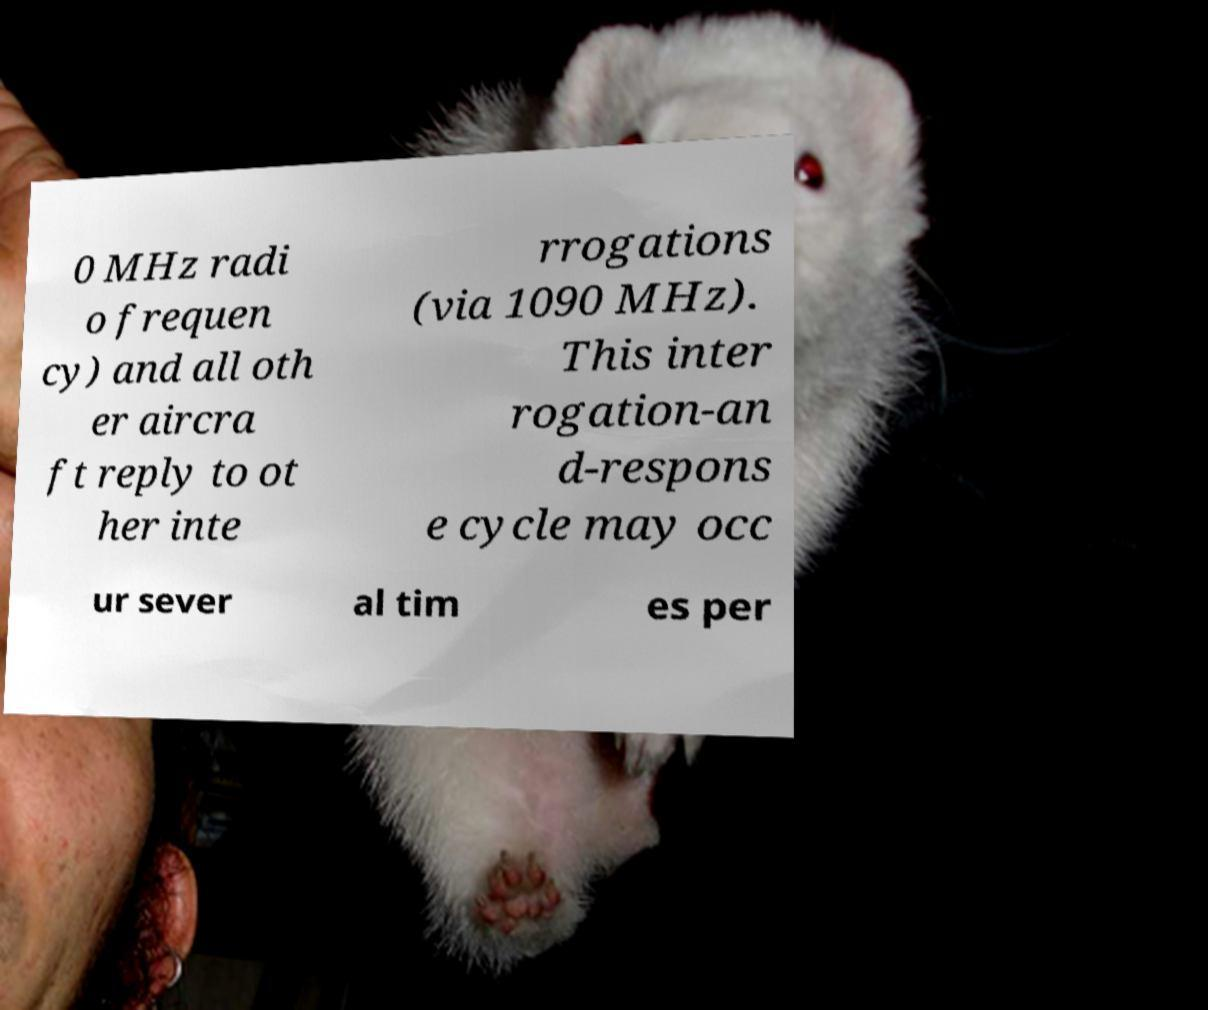Please read and relay the text visible in this image. What does it say? 0 MHz radi o frequen cy) and all oth er aircra ft reply to ot her inte rrogations (via 1090 MHz). This inter rogation-an d-respons e cycle may occ ur sever al tim es per 